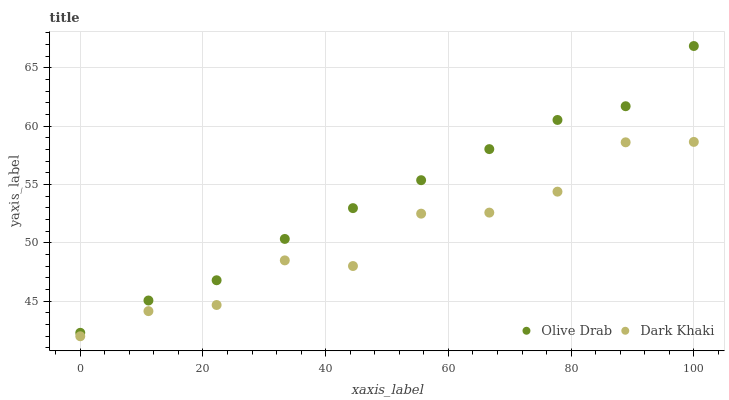Does Dark Khaki have the minimum area under the curve?
Answer yes or no. Yes. Does Olive Drab have the maximum area under the curve?
Answer yes or no. Yes. Does Olive Drab have the minimum area under the curve?
Answer yes or no. No. Is Olive Drab the smoothest?
Answer yes or no. Yes. Is Dark Khaki the roughest?
Answer yes or no. Yes. Is Olive Drab the roughest?
Answer yes or no. No. Does Dark Khaki have the lowest value?
Answer yes or no. Yes. Does Olive Drab have the lowest value?
Answer yes or no. No. Does Olive Drab have the highest value?
Answer yes or no. Yes. Is Dark Khaki less than Olive Drab?
Answer yes or no. Yes. Is Olive Drab greater than Dark Khaki?
Answer yes or no. Yes. Does Dark Khaki intersect Olive Drab?
Answer yes or no. No. 